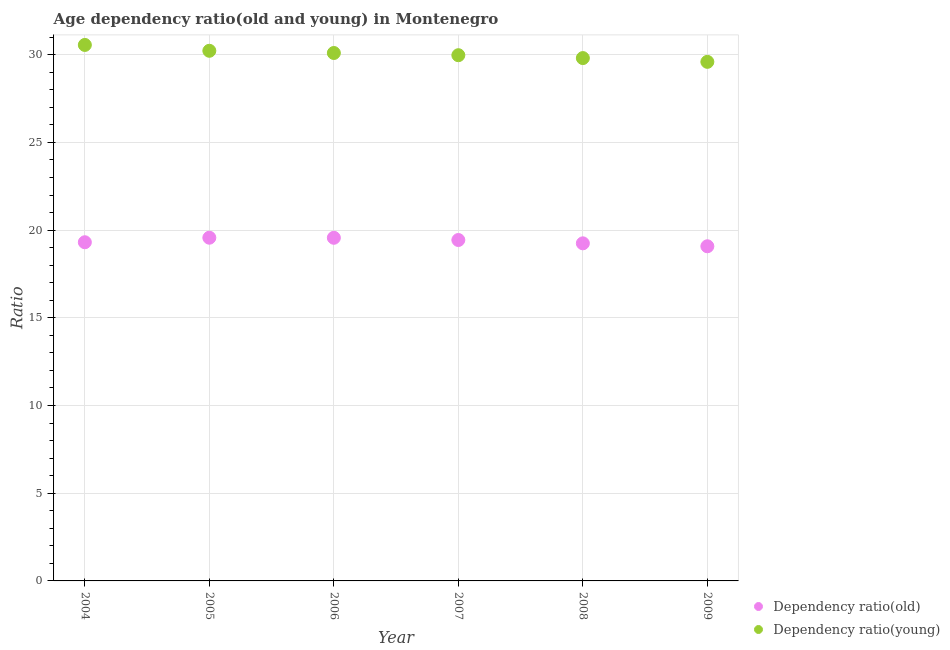How many different coloured dotlines are there?
Keep it short and to the point. 2. What is the age dependency ratio(young) in 2006?
Keep it short and to the point. 30.1. Across all years, what is the maximum age dependency ratio(old)?
Your answer should be compact. 19.57. Across all years, what is the minimum age dependency ratio(old)?
Your answer should be compact. 19.08. In which year was the age dependency ratio(old) maximum?
Keep it short and to the point. 2005. In which year was the age dependency ratio(young) minimum?
Offer a very short reply. 2009. What is the total age dependency ratio(young) in the graph?
Make the answer very short. 180.27. What is the difference between the age dependency ratio(young) in 2005 and that in 2007?
Make the answer very short. 0.25. What is the difference between the age dependency ratio(young) in 2005 and the age dependency ratio(old) in 2009?
Offer a very short reply. 11.15. What is the average age dependency ratio(old) per year?
Give a very brief answer. 19.37. In the year 2009, what is the difference between the age dependency ratio(young) and age dependency ratio(old)?
Offer a very short reply. 10.52. What is the ratio of the age dependency ratio(young) in 2005 to that in 2007?
Provide a succinct answer. 1.01. Is the age dependency ratio(young) in 2005 less than that in 2006?
Offer a terse response. No. Is the difference between the age dependency ratio(old) in 2004 and 2007 greater than the difference between the age dependency ratio(young) in 2004 and 2007?
Provide a succinct answer. No. What is the difference between the highest and the second highest age dependency ratio(old)?
Your answer should be compact. 0. What is the difference between the highest and the lowest age dependency ratio(young)?
Your response must be concise. 0.96. In how many years, is the age dependency ratio(old) greater than the average age dependency ratio(old) taken over all years?
Provide a short and direct response. 3. Does the age dependency ratio(old) monotonically increase over the years?
Your answer should be very brief. No. Is the age dependency ratio(young) strictly greater than the age dependency ratio(old) over the years?
Ensure brevity in your answer.  Yes. How many dotlines are there?
Provide a succinct answer. 2. How many years are there in the graph?
Provide a succinct answer. 6. Are the values on the major ticks of Y-axis written in scientific E-notation?
Your answer should be very brief. No. Does the graph contain grids?
Keep it short and to the point. Yes. How many legend labels are there?
Make the answer very short. 2. What is the title of the graph?
Make the answer very short. Age dependency ratio(old and young) in Montenegro. What is the label or title of the Y-axis?
Your response must be concise. Ratio. What is the Ratio of Dependency ratio(old) in 2004?
Make the answer very short. 19.31. What is the Ratio in Dependency ratio(young) in 2004?
Offer a terse response. 30.56. What is the Ratio of Dependency ratio(old) in 2005?
Your answer should be very brief. 19.57. What is the Ratio of Dependency ratio(young) in 2005?
Offer a very short reply. 30.23. What is the Ratio in Dependency ratio(old) in 2006?
Your answer should be very brief. 19.56. What is the Ratio of Dependency ratio(young) in 2006?
Give a very brief answer. 30.1. What is the Ratio of Dependency ratio(old) in 2007?
Your answer should be compact. 19.44. What is the Ratio in Dependency ratio(young) in 2007?
Your response must be concise. 29.97. What is the Ratio of Dependency ratio(old) in 2008?
Keep it short and to the point. 19.25. What is the Ratio in Dependency ratio(young) in 2008?
Keep it short and to the point. 29.81. What is the Ratio of Dependency ratio(old) in 2009?
Ensure brevity in your answer.  19.08. What is the Ratio in Dependency ratio(young) in 2009?
Ensure brevity in your answer.  29.6. Across all years, what is the maximum Ratio of Dependency ratio(old)?
Offer a terse response. 19.57. Across all years, what is the maximum Ratio in Dependency ratio(young)?
Provide a short and direct response. 30.56. Across all years, what is the minimum Ratio of Dependency ratio(old)?
Your response must be concise. 19.08. Across all years, what is the minimum Ratio in Dependency ratio(young)?
Your answer should be very brief. 29.6. What is the total Ratio of Dependency ratio(old) in the graph?
Your response must be concise. 116.21. What is the total Ratio of Dependency ratio(young) in the graph?
Keep it short and to the point. 180.27. What is the difference between the Ratio of Dependency ratio(old) in 2004 and that in 2005?
Ensure brevity in your answer.  -0.26. What is the difference between the Ratio of Dependency ratio(young) in 2004 and that in 2005?
Ensure brevity in your answer.  0.33. What is the difference between the Ratio of Dependency ratio(old) in 2004 and that in 2006?
Your answer should be very brief. -0.25. What is the difference between the Ratio in Dependency ratio(young) in 2004 and that in 2006?
Make the answer very short. 0.46. What is the difference between the Ratio of Dependency ratio(old) in 2004 and that in 2007?
Your answer should be compact. -0.13. What is the difference between the Ratio of Dependency ratio(young) in 2004 and that in 2007?
Your answer should be compact. 0.58. What is the difference between the Ratio in Dependency ratio(old) in 2004 and that in 2008?
Your answer should be compact. 0.06. What is the difference between the Ratio of Dependency ratio(young) in 2004 and that in 2008?
Your answer should be compact. 0.75. What is the difference between the Ratio of Dependency ratio(old) in 2004 and that in 2009?
Your answer should be very brief. 0.23. What is the difference between the Ratio of Dependency ratio(young) in 2004 and that in 2009?
Make the answer very short. 0.96. What is the difference between the Ratio in Dependency ratio(old) in 2005 and that in 2006?
Your answer should be compact. 0. What is the difference between the Ratio of Dependency ratio(young) in 2005 and that in 2006?
Ensure brevity in your answer.  0.13. What is the difference between the Ratio in Dependency ratio(old) in 2005 and that in 2007?
Give a very brief answer. 0.13. What is the difference between the Ratio of Dependency ratio(young) in 2005 and that in 2007?
Provide a succinct answer. 0.25. What is the difference between the Ratio of Dependency ratio(old) in 2005 and that in 2008?
Offer a very short reply. 0.32. What is the difference between the Ratio in Dependency ratio(young) in 2005 and that in 2008?
Keep it short and to the point. 0.42. What is the difference between the Ratio in Dependency ratio(old) in 2005 and that in 2009?
Ensure brevity in your answer.  0.49. What is the difference between the Ratio of Dependency ratio(young) in 2005 and that in 2009?
Your answer should be compact. 0.63. What is the difference between the Ratio of Dependency ratio(old) in 2006 and that in 2007?
Give a very brief answer. 0.13. What is the difference between the Ratio in Dependency ratio(young) in 2006 and that in 2007?
Provide a short and direct response. 0.13. What is the difference between the Ratio of Dependency ratio(old) in 2006 and that in 2008?
Your answer should be very brief. 0.32. What is the difference between the Ratio of Dependency ratio(young) in 2006 and that in 2008?
Provide a succinct answer. 0.29. What is the difference between the Ratio of Dependency ratio(old) in 2006 and that in 2009?
Provide a short and direct response. 0.48. What is the difference between the Ratio in Dependency ratio(young) in 2006 and that in 2009?
Make the answer very short. 0.5. What is the difference between the Ratio in Dependency ratio(old) in 2007 and that in 2008?
Your answer should be compact. 0.19. What is the difference between the Ratio of Dependency ratio(young) in 2007 and that in 2008?
Make the answer very short. 0.16. What is the difference between the Ratio in Dependency ratio(old) in 2007 and that in 2009?
Offer a terse response. 0.36. What is the difference between the Ratio in Dependency ratio(young) in 2007 and that in 2009?
Offer a terse response. 0.38. What is the difference between the Ratio of Dependency ratio(old) in 2008 and that in 2009?
Your answer should be compact. 0.17. What is the difference between the Ratio in Dependency ratio(young) in 2008 and that in 2009?
Keep it short and to the point. 0.22. What is the difference between the Ratio of Dependency ratio(old) in 2004 and the Ratio of Dependency ratio(young) in 2005?
Your answer should be very brief. -10.92. What is the difference between the Ratio of Dependency ratio(old) in 2004 and the Ratio of Dependency ratio(young) in 2006?
Your answer should be very brief. -10.79. What is the difference between the Ratio of Dependency ratio(old) in 2004 and the Ratio of Dependency ratio(young) in 2007?
Your answer should be very brief. -10.66. What is the difference between the Ratio in Dependency ratio(old) in 2004 and the Ratio in Dependency ratio(young) in 2008?
Your answer should be compact. -10.5. What is the difference between the Ratio of Dependency ratio(old) in 2004 and the Ratio of Dependency ratio(young) in 2009?
Your answer should be very brief. -10.29. What is the difference between the Ratio of Dependency ratio(old) in 2005 and the Ratio of Dependency ratio(young) in 2006?
Keep it short and to the point. -10.53. What is the difference between the Ratio of Dependency ratio(old) in 2005 and the Ratio of Dependency ratio(young) in 2007?
Keep it short and to the point. -10.41. What is the difference between the Ratio of Dependency ratio(old) in 2005 and the Ratio of Dependency ratio(young) in 2008?
Ensure brevity in your answer.  -10.24. What is the difference between the Ratio of Dependency ratio(old) in 2005 and the Ratio of Dependency ratio(young) in 2009?
Keep it short and to the point. -10.03. What is the difference between the Ratio of Dependency ratio(old) in 2006 and the Ratio of Dependency ratio(young) in 2007?
Your answer should be compact. -10.41. What is the difference between the Ratio of Dependency ratio(old) in 2006 and the Ratio of Dependency ratio(young) in 2008?
Your answer should be compact. -10.25. What is the difference between the Ratio of Dependency ratio(old) in 2006 and the Ratio of Dependency ratio(young) in 2009?
Offer a very short reply. -10.03. What is the difference between the Ratio in Dependency ratio(old) in 2007 and the Ratio in Dependency ratio(young) in 2008?
Keep it short and to the point. -10.37. What is the difference between the Ratio of Dependency ratio(old) in 2007 and the Ratio of Dependency ratio(young) in 2009?
Make the answer very short. -10.16. What is the difference between the Ratio in Dependency ratio(old) in 2008 and the Ratio in Dependency ratio(young) in 2009?
Make the answer very short. -10.35. What is the average Ratio of Dependency ratio(old) per year?
Keep it short and to the point. 19.37. What is the average Ratio of Dependency ratio(young) per year?
Your answer should be compact. 30.04. In the year 2004, what is the difference between the Ratio of Dependency ratio(old) and Ratio of Dependency ratio(young)?
Offer a terse response. -11.25. In the year 2005, what is the difference between the Ratio of Dependency ratio(old) and Ratio of Dependency ratio(young)?
Give a very brief answer. -10.66. In the year 2006, what is the difference between the Ratio in Dependency ratio(old) and Ratio in Dependency ratio(young)?
Give a very brief answer. -10.54. In the year 2007, what is the difference between the Ratio in Dependency ratio(old) and Ratio in Dependency ratio(young)?
Your answer should be compact. -10.54. In the year 2008, what is the difference between the Ratio of Dependency ratio(old) and Ratio of Dependency ratio(young)?
Offer a terse response. -10.56. In the year 2009, what is the difference between the Ratio of Dependency ratio(old) and Ratio of Dependency ratio(young)?
Make the answer very short. -10.52. What is the ratio of the Ratio of Dependency ratio(old) in 2004 to that in 2006?
Your answer should be compact. 0.99. What is the ratio of the Ratio in Dependency ratio(young) in 2004 to that in 2006?
Provide a succinct answer. 1.02. What is the ratio of the Ratio of Dependency ratio(old) in 2004 to that in 2007?
Offer a very short reply. 0.99. What is the ratio of the Ratio in Dependency ratio(young) in 2004 to that in 2007?
Provide a short and direct response. 1.02. What is the ratio of the Ratio of Dependency ratio(old) in 2004 to that in 2008?
Provide a succinct answer. 1. What is the ratio of the Ratio in Dependency ratio(young) in 2004 to that in 2008?
Keep it short and to the point. 1.03. What is the ratio of the Ratio in Dependency ratio(old) in 2004 to that in 2009?
Give a very brief answer. 1.01. What is the ratio of the Ratio of Dependency ratio(young) in 2004 to that in 2009?
Your response must be concise. 1.03. What is the ratio of the Ratio of Dependency ratio(old) in 2005 to that in 2006?
Make the answer very short. 1. What is the ratio of the Ratio of Dependency ratio(young) in 2005 to that in 2006?
Offer a terse response. 1. What is the ratio of the Ratio in Dependency ratio(young) in 2005 to that in 2007?
Make the answer very short. 1.01. What is the ratio of the Ratio of Dependency ratio(old) in 2005 to that in 2008?
Provide a short and direct response. 1.02. What is the ratio of the Ratio of Dependency ratio(young) in 2005 to that in 2008?
Your response must be concise. 1.01. What is the ratio of the Ratio of Dependency ratio(old) in 2005 to that in 2009?
Provide a short and direct response. 1.03. What is the ratio of the Ratio of Dependency ratio(young) in 2005 to that in 2009?
Keep it short and to the point. 1.02. What is the ratio of the Ratio of Dependency ratio(old) in 2006 to that in 2007?
Provide a succinct answer. 1.01. What is the ratio of the Ratio in Dependency ratio(old) in 2006 to that in 2008?
Make the answer very short. 1.02. What is the ratio of the Ratio of Dependency ratio(young) in 2006 to that in 2008?
Provide a succinct answer. 1.01. What is the ratio of the Ratio of Dependency ratio(old) in 2006 to that in 2009?
Your response must be concise. 1.03. What is the ratio of the Ratio in Dependency ratio(young) in 2006 to that in 2009?
Ensure brevity in your answer.  1.02. What is the ratio of the Ratio of Dependency ratio(old) in 2007 to that in 2008?
Give a very brief answer. 1.01. What is the ratio of the Ratio of Dependency ratio(old) in 2007 to that in 2009?
Give a very brief answer. 1.02. What is the ratio of the Ratio of Dependency ratio(young) in 2007 to that in 2009?
Make the answer very short. 1.01. What is the ratio of the Ratio of Dependency ratio(old) in 2008 to that in 2009?
Your answer should be very brief. 1.01. What is the ratio of the Ratio of Dependency ratio(young) in 2008 to that in 2009?
Your answer should be compact. 1.01. What is the difference between the highest and the second highest Ratio of Dependency ratio(old)?
Ensure brevity in your answer.  0. What is the difference between the highest and the second highest Ratio of Dependency ratio(young)?
Provide a short and direct response. 0.33. What is the difference between the highest and the lowest Ratio of Dependency ratio(old)?
Offer a very short reply. 0.49. What is the difference between the highest and the lowest Ratio in Dependency ratio(young)?
Provide a succinct answer. 0.96. 